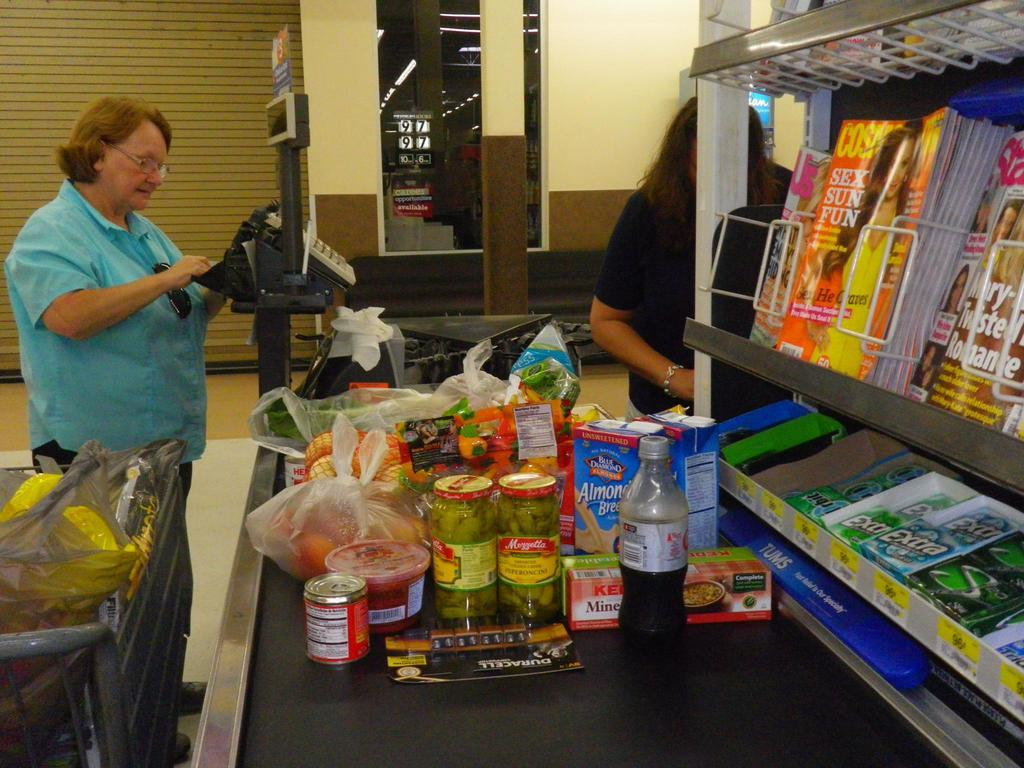<image>
Provide a brief description of the given image. An older woman buys groceries while a Cosmopolitan advertises Sex, Sun, and Fun 